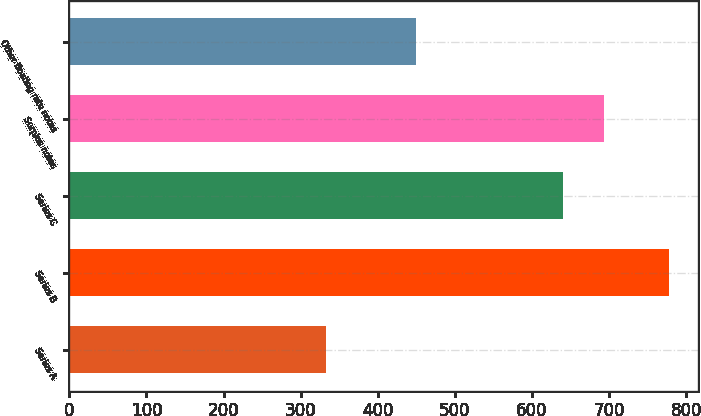Convert chart to OTSL. <chart><loc_0><loc_0><loc_500><loc_500><bar_chart><fcel>Series A<fcel>Series B<fcel>Series C<fcel>Surplus notes<fcel>Other floating rate notes<nl><fcel>333<fcel>777<fcel>640<fcel>693<fcel>450<nl></chart> 